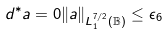Convert formula to latex. <formula><loc_0><loc_0><loc_500><loc_500>d ^ { * } a = 0 \| a \| _ { L ^ { 7 / 2 } _ { 1 } ( \mathbb { B } ) } \leq \epsilon _ { 6 }</formula> 